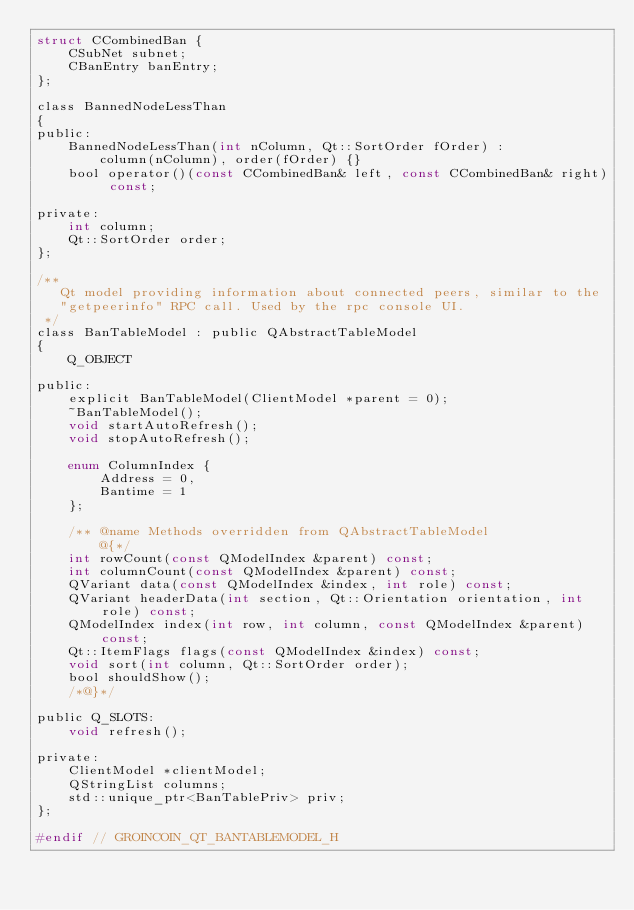<code> <loc_0><loc_0><loc_500><loc_500><_C_>struct CCombinedBan {
    CSubNet subnet;
    CBanEntry banEntry;
};

class BannedNodeLessThan
{
public:
    BannedNodeLessThan(int nColumn, Qt::SortOrder fOrder) :
        column(nColumn), order(fOrder) {}
    bool operator()(const CCombinedBan& left, const CCombinedBan& right) const;

private:
    int column;
    Qt::SortOrder order;
};

/**
   Qt model providing information about connected peers, similar to the
   "getpeerinfo" RPC call. Used by the rpc console UI.
 */
class BanTableModel : public QAbstractTableModel
{
    Q_OBJECT

public:
    explicit BanTableModel(ClientModel *parent = 0);
    ~BanTableModel();
    void startAutoRefresh();
    void stopAutoRefresh();

    enum ColumnIndex {
        Address = 0,
        Bantime = 1
    };

    /** @name Methods overridden from QAbstractTableModel
        @{*/
    int rowCount(const QModelIndex &parent) const;
    int columnCount(const QModelIndex &parent) const;
    QVariant data(const QModelIndex &index, int role) const;
    QVariant headerData(int section, Qt::Orientation orientation, int role) const;
    QModelIndex index(int row, int column, const QModelIndex &parent) const;
    Qt::ItemFlags flags(const QModelIndex &index) const;
    void sort(int column, Qt::SortOrder order);
    bool shouldShow();
    /*@}*/

public Q_SLOTS:
    void refresh();

private:
    ClientModel *clientModel;
    QStringList columns;
    std::unique_ptr<BanTablePriv> priv;
};

#endif // GROINCOIN_QT_BANTABLEMODEL_H
</code> 